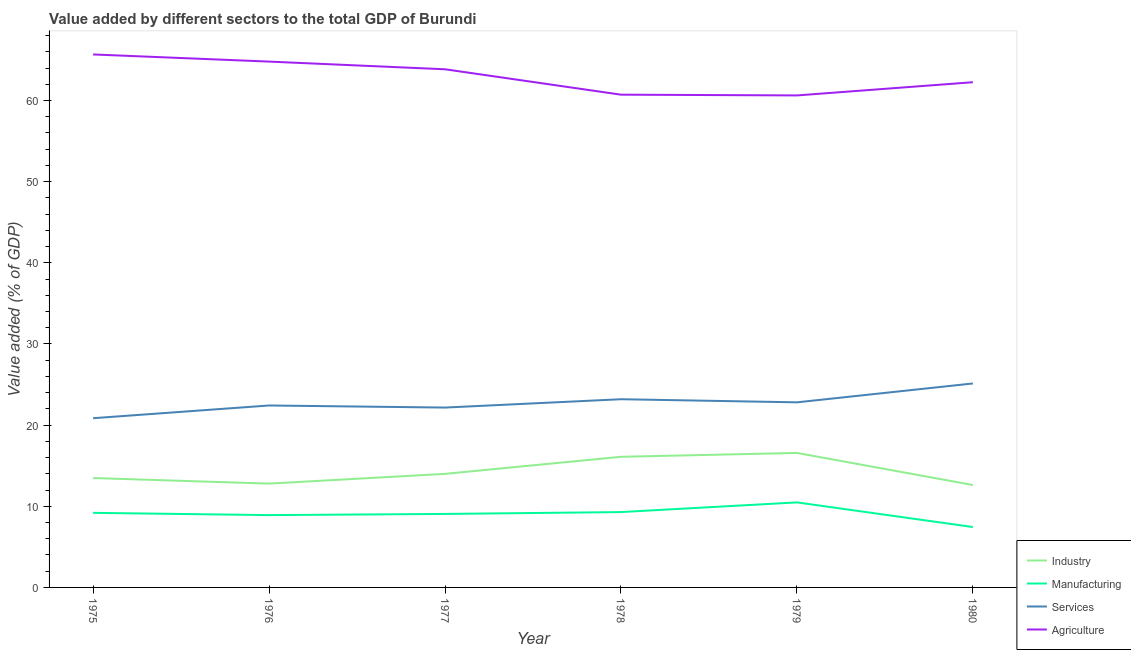How many different coloured lines are there?
Your answer should be very brief. 4. Is the number of lines equal to the number of legend labels?
Offer a very short reply. Yes. What is the value added by agricultural sector in 1976?
Provide a short and direct response. 64.79. Across all years, what is the maximum value added by industrial sector?
Provide a succinct answer. 16.57. Across all years, what is the minimum value added by industrial sector?
Offer a terse response. 12.62. In which year was the value added by services sector maximum?
Ensure brevity in your answer.  1980. In which year was the value added by agricultural sector minimum?
Provide a succinct answer. 1979. What is the total value added by agricultural sector in the graph?
Offer a very short reply. 377.89. What is the difference between the value added by manufacturing sector in 1975 and that in 1979?
Offer a terse response. -1.29. What is the difference between the value added by industrial sector in 1978 and the value added by manufacturing sector in 1975?
Provide a short and direct response. 6.91. What is the average value added by agricultural sector per year?
Your answer should be compact. 62.98. In the year 1979, what is the difference between the value added by manufacturing sector and value added by services sector?
Ensure brevity in your answer.  -12.33. What is the ratio of the value added by industrial sector in 1976 to that in 1978?
Give a very brief answer. 0.79. What is the difference between the highest and the second highest value added by industrial sector?
Offer a terse response. 0.48. What is the difference between the highest and the lowest value added by services sector?
Offer a very short reply. 4.28. In how many years, is the value added by industrial sector greater than the average value added by industrial sector taken over all years?
Provide a succinct answer. 2. Is the sum of the value added by services sector in 1976 and 1979 greater than the maximum value added by industrial sector across all years?
Ensure brevity in your answer.  Yes. Is the value added by agricultural sector strictly less than the value added by industrial sector over the years?
Provide a succinct answer. No. How many years are there in the graph?
Ensure brevity in your answer.  6. Does the graph contain grids?
Give a very brief answer. No. How are the legend labels stacked?
Provide a succinct answer. Vertical. What is the title of the graph?
Keep it short and to the point. Value added by different sectors to the total GDP of Burundi. Does "Minerals" appear as one of the legend labels in the graph?
Your response must be concise. No. What is the label or title of the Y-axis?
Offer a terse response. Value added (% of GDP). What is the Value added (% of GDP) in Industry in 1975?
Ensure brevity in your answer.  13.48. What is the Value added (% of GDP) of Manufacturing in 1975?
Provide a short and direct response. 9.19. What is the Value added (% of GDP) in Services in 1975?
Make the answer very short. 20.85. What is the Value added (% of GDP) in Agriculture in 1975?
Offer a very short reply. 65.67. What is the Value added (% of GDP) of Industry in 1976?
Provide a succinct answer. 12.79. What is the Value added (% of GDP) of Manufacturing in 1976?
Provide a short and direct response. 8.91. What is the Value added (% of GDP) of Services in 1976?
Your answer should be very brief. 22.42. What is the Value added (% of GDP) in Agriculture in 1976?
Give a very brief answer. 64.79. What is the Value added (% of GDP) of Industry in 1977?
Give a very brief answer. 13.99. What is the Value added (% of GDP) of Manufacturing in 1977?
Provide a short and direct response. 9.05. What is the Value added (% of GDP) in Services in 1977?
Make the answer very short. 22.16. What is the Value added (% of GDP) in Agriculture in 1977?
Offer a very short reply. 63.84. What is the Value added (% of GDP) of Industry in 1978?
Your response must be concise. 16.1. What is the Value added (% of GDP) of Manufacturing in 1978?
Your answer should be compact. 9.29. What is the Value added (% of GDP) in Services in 1978?
Ensure brevity in your answer.  23.19. What is the Value added (% of GDP) of Agriculture in 1978?
Provide a short and direct response. 60.71. What is the Value added (% of GDP) of Industry in 1979?
Offer a terse response. 16.57. What is the Value added (% of GDP) of Manufacturing in 1979?
Offer a very short reply. 10.48. What is the Value added (% of GDP) in Services in 1979?
Provide a short and direct response. 22.81. What is the Value added (% of GDP) of Agriculture in 1979?
Your answer should be compact. 60.62. What is the Value added (% of GDP) of Industry in 1980?
Your response must be concise. 12.62. What is the Value added (% of GDP) in Manufacturing in 1980?
Make the answer very short. 7.44. What is the Value added (% of GDP) in Services in 1980?
Give a very brief answer. 25.13. What is the Value added (% of GDP) in Agriculture in 1980?
Ensure brevity in your answer.  62.25. Across all years, what is the maximum Value added (% of GDP) in Industry?
Ensure brevity in your answer.  16.57. Across all years, what is the maximum Value added (% of GDP) of Manufacturing?
Ensure brevity in your answer.  10.48. Across all years, what is the maximum Value added (% of GDP) of Services?
Your response must be concise. 25.13. Across all years, what is the maximum Value added (% of GDP) of Agriculture?
Make the answer very short. 65.67. Across all years, what is the minimum Value added (% of GDP) of Industry?
Provide a short and direct response. 12.62. Across all years, what is the minimum Value added (% of GDP) of Manufacturing?
Your answer should be compact. 7.44. Across all years, what is the minimum Value added (% of GDP) of Services?
Your answer should be compact. 20.85. Across all years, what is the minimum Value added (% of GDP) of Agriculture?
Offer a very short reply. 60.62. What is the total Value added (% of GDP) in Industry in the graph?
Provide a short and direct response. 85.55. What is the total Value added (% of GDP) of Manufacturing in the graph?
Your response must be concise. 54.36. What is the total Value added (% of GDP) of Services in the graph?
Your response must be concise. 136.56. What is the total Value added (% of GDP) in Agriculture in the graph?
Your response must be concise. 377.89. What is the difference between the Value added (% of GDP) of Industry in 1975 and that in 1976?
Your answer should be very brief. 0.69. What is the difference between the Value added (% of GDP) in Manufacturing in 1975 and that in 1976?
Ensure brevity in your answer.  0.28. What is the difference between the Value added (% of GDP) in Services in 1975 and that in 1976?
Give a very brief answer. -1.57. What is the difference between the Value added (% of GDP) of Agriculture in 1975 and that in 1976?
Provide a succinct answer. 0.88. What is the difference between the Value added (% of GDP) in Industry in 1975 and that in 1977?
Make the answer very short. -0.51. What is the difference between the Value added (% of GDP) in Manufacturing in 1975 and that in 1977?
Your answer should be compact. 0.13. What is the difference between the Value added (% of GDP) of Services in 1975 and that in 1977?
Offer a terse response. -1.31. What is the difference between the Value added (% of GDP) of Agriculture in 1975 and that in 1977?
Your answer should be very brief. 1.83. What is the difference between the Value added (% of GDP) of Industry in 1975 and that in 1978?
Provide a succinct answer. -2.62. What is the difference between the Value added (% of GDP) in Manufacturing in 1975 and that in 1978?
Provide a succinct answer. -0.1. What is the difference between the Value added (% of GDP) of Services in 1975 and that in 1978?
Offer a very short reply. -2.34. What is the difference between the Value added (% of GDP) of Agriculture in 1975 and that in 1978?
Your answer should be very brief. 4.96. What is the difference between the Value added (% of GDP) in Industry in 1975 and that in 1979?
Your response must be concise. -3.09. What is the difference between the Value added (% of GDP) of Manufacturing in 1975 and that in 1979?
Give a very brief answer. -1.29. What is the difference between the Value added (% of GDP) of Services in 1975 and that in 1979?
Keep it short and to the point. -1.96. What is the difference between the Value added (% of GDP) of Agriculture in 1975 and that in 1979?
Your answer should be very brief. 5.05. What is the difference between the Value added (% of GDP) in Industry in 1975 and that in 1980?
Keep it short and to the point. 0.86. What is the difference between the Value added (% of GDP) in Manufacturing in 1975 and that in 1980?
Give a very brief answer. 1.75. What is the difference between the Value added (% of GDP) of Services in 1975 and that in 1980?
Provide a short and direct response. -4.28. What is the difference between the Value added (% of GDP) of Agriculture in 1975 and that in 1980?
Your answer should be compact. 3.42. What is the difference between the Value added (% of GDP) in Industry in 1976 and that in 1977?
Provide a short and direct response. -1.2. What is the difference between the Value added (% of GDP) in Manufacturing in 1976 and that in 1977?
Keep it short and to the point. -0.14. What is the difference between the Value added (% of GDP) in Services in 1976 and that in 1977?
Offer a terse response. 0.26. What is the difference between the Value added (% of GDP) of Agriculture in 1976 and that in 1977?
Ensure brevity in your answer.  0.95. What is the difference between the Value added (% of GDP) in Industry in 1976 and that in 1978?
Offer a terse response. -3.3. What is the difference between the Value added (% of GDP) of Manufacturing in 1976 and that in 1978?
Keep it short and to the point. -0.37. What is the difference between the Value added (% of GDP) of Services in 1976 and that in 1978?
Keep it short and to the point. -0.77. What is the difference between the Value added (% of GDP) of Agriculture in 1976 and that in 1978?
Your answer should be compact. 4.08. What is the difference between the Value added (% of GDP) in Industry in 1976 and that in 1979?
Provide a succinct answer. -3.78. What is the difference between the Value added (% of GDP) of Manufacturing in 1976 and that in 1979?
Provide a short and direct response. -1.57. What is the difference between the Value added (% of GDP) of Services in 1976 and that in 1979?
Give a very brief answer. -0.39. What is the difference between the Value added (% of GDP) in Agriculture in 1976 and that in 1979?
Keep it short and to the point. 4.17. What is the difference between the Value added (% of GDP) in Industry in 1976 and that in 1980?
Your answer should be compact. 0.17. What is the difference between the Value added (% of GDP) in Manufacturing in 1976 and that in 1980?
Your answer should be compact. 1.47. What is the difference between the Value added (% of GDP) of Services in 1976 and that in 1980?
Your response must be concise. -2.71. What is the difference between the Value added (% of GDP) of Agriculture in 1976 and that in 1980?
Your answer should be very brief. 2.54. What is the difference between the Value added (% of GDP) in Industry in 1977 and that in 1978?
Provide a succinct answer. -2.1. What is the difference between the Value added (% of GDP) of Manufacturing in 1977 and that in 1978?
Make the answer very short. -0.23. What is the difference between the Value added (% of GDP) of Services in 1977 and that in 1978?
Your response must be concise. -1.03. What is the difference between the Value added (% of GDP) in Agriculture in 1977 and that in 1978?
Your answer should be compact. 3.13. What is the difference between the Value added (% of GDP) of Industry in 1977 and that in 1979?
Keep it short and to the point. -2.58. What is the difference between the Value added (% of GDP) of Manufacturing in 1977 and that in 1979?
Give a very brief answer. -1.42. What is the difference between the Value added (% of GDP) in Services in 1977 and that in 1979?
Give a very brief answer. -0.64. What is the difference between the Value added (% of GDP) in Agriculture in 1977 and that in 1979?
Ensure brevity in your answer.  3.22. What is the difference between the Value added (% of GDP) of Industry in 1977 and that in 1980?
Your answer should be very brief. 1.37. What is the difference between the Value added (% of GDP) in Manufacturing in 1977 and that in 1980?
Your answer should be compact. 1.61. What is the difference between the Value added (% of GDP) of Services in 1977 and that in 1980?
Ensure brevity in your answer.  -2.97. What is the difference between the Value added (% of GDP) in Agriculture in 1977 and that in 1980?
Your answer should be very brief. 1.59. What is the difference between the Value added (% of GDP) in Industry in 1978 and that in 1979?
Offer a very short reply. -0.48. What is the difference between the Value added (% of GDP) in Manufacturing in 1978 and that in 1979?
Keep it short and to the point. -1.19. What is the difference between the Value added (% of GDP) of Services in 1978 and that in 1979?
Provide a succinct answer. 0.38. What is the difference between the Value added (% of GDP) of Agriculture in 1978 and that in 1979?
Keep it short and to the point. 0.09. What is the difference between the Value added (% of GDP) in Industry in 1978 and that in 1980?
Offer a very short reply. 3.48. What is the difference between the Value added (% of GDP) of Manufacturing in 1978 and that in 1980?
Give a very brief answer. 1.84. What is the difference between the Value added (% of GDP) of Services in 1978 and that in 1980?
Ensure brevity in your answer.  -1.94. What is the difference between the Value added (% of GDP) in Agriculture in 1978 and that in 1980?
Ensure brevity in your answer.  -1.54. What is the difference between the Value added (% of GDP) of Industry in 1979 and that in 1980?
Offer a very short reply. 3.95. What is the difference between the Value added (% of GDP) of Manufacturing in 1979 and that in 1980?
Keep it short and to the point. 3.04. What is the difference between the Value added (% of GDP) of Services in 1979 and that in 1980?
Provide a succinct answer. -2.32. What is the difference between the Value added (% of GDP) of Agriculture in 1979 and that in 1980?
Your answer should be compact. -1.63. What is the difference between the Value added (% of GDP) in Industry in 1975 and the Value added (% of GDP) in Manufacturing in 1976?
Give a very brief answer. 4.57. What is the difference between the Value added (% of GDP) in Industry in 1975 and the Value added (% of GDP) in Services in 1976?
Offer a very short reply. -8.94. What is the difference between the Value added (% of GDP) in Industry in 1975 and the Value added (% of GDP) in Agriculture in 1976?
Your answer should be compact. -51.31. What is the difference between the Value added (% of GDP) of Manufacturing in 1975 and the Value added (% of GDP) of Services in 1976?
Make the answer very short. -13.23. What is the difference between the Value added (% of GDP) of Manufacturing in 1975 and the Value added (% of GDP) of Agriculture in 1976?
Offer a very short reply. -55.6. What is the difference between the Value added (% of GDP) in Services in 1975 and the Value added (% of GDP) in Agriculture in 1976?
Offer a very short reply. -43.94. What is the difference between the Value added (% of GDP) in Industry in 1975 and the Value added (% of GDP) in Manufacturing in 1977?
Offer a terse response. 4.42. What is the difference between the Value added (% of GDP) of Industry in 1975 and the Value added (% of GDP) of Services in 1977?
Your answer should be compact. -8.68. What is the difference between the Value added (% of GDP) in Industry in 1975 and the Value added (% of GDP) in Agriculture in 1977?
Make the answer very short. -50.37. What is the difference between the Value added (% of GDP) of Manufacturing in 1975 and the Value added (% of GDP) of Services in 1977?
Offer a terse response. -12.97. What is the difference between the Value added (% of GDP) in Manufacturing in 1975 and the Value added (% of GDP) in Agriculture in 1977?
Provide a succinct answer. -54.66. What is the difference between the Value added (% of GDP) of Services in 1975 and the Value added (% of GDP) of Agriculture in 1977?
Give a very brief answer. -42.99. What is the difference between the Value added (% of GDP) of Industry in 1975 and the Value added (% of GDP) of Manufacturing in 1978?
Provide a short and direct response. 4.19. What is the difference between the Value added (% of GDP) in Industry in 1975 and the Value added (% of GDP) in Services in 1978?
Provide a short and direct response. -9.71. What is the difference between the Value added (% of GDP) in Industry in 1975 and the Value added (% of GDP) in Agriculture in 1978?
Offer a terse response. -47.24. What is the difference between the Value added (% of GDP) of Manufacturing in 1975 and the Value added (% of GDP) of Services in 1978?
Give a very brief answer. -14. What is the difference between the Value added (% of GDP) of Manufacturing in 1975 and the Value added (% of GDP) of Agriculture in 1978?
Offer a terse response. -51.53. What is the difference between the Value added (% of GDP) in Services in 1975 and the Value added (% of GDP) in Agriculture in 1978?
Provide a succinct answer. -39.86. What is the difference between the Value added (% of GDP) in Industry in 1975 and the Value added (% of GDP) in Manufacturing in 1979?
Make the answer very short. 3. What is the difference between the Value added (% of GDP) of Industry in 1975 and the Value added (% of GDP) of Services in 1979?
Give a very brief answer. -9.33. What is the difference between the Value added (% of GDP) in Industry in 1975 and the Value added (% of GDP) in Agriculture in 1979?
Make the answer very short. -47.14. What is the difference between the Value added (% of GDP) in Manufacturing in 1975 and the Value added (% of GDP) in Services in 1979?
Give a very brief answer. -13.62. What is the difference between the Value added (% of GDP) in Manufacturing in 1975 and the Value added (% of GDP) in Agriculture in 1979?
Offer a very short reply. -51.43. What is the difference between the Value added (% of GDP) of Services in 1975 and the Value added (% of GDP) of Agriculture in 1979?
Ensure brevity in your answer.  -39.77. What is the difference between the Value added (% of GDP) of Industry in 1975 and the Value added (% of GDP) of Manufacturing in 1980?
Your answer should be compact. 6.04. What is the difference between the Value added (% of GDP) of Industry in 1975 and the Value added (% of GDP) of Services in 1980?
Keep it short and to the point. -11.65. What is the difference between the Value added (% of GDP) of Industry in 1975 and the Value added (% of GDP) of Agriculture in 1980?
Keep it short and to the point. -48.77. What is the difference between the Value added (% of GDP) of Manufacturing in 1975 and the Value added (% of GDP) of Services in 1980?
Offer a very short reply. -15.94. What is the difference between the Value added (% of GDP) of Manufacturing in 1975 and the Value added (% of GDP) of Agriculture in 1980?
Keep it short and to the point. -53.06. What is the difference between the Value added (% of GDP) of Services in 1975 and the Value added (% of GDP) of Agriculture in 1980?
Give a very brief answer. -41.4. What is the difference between the Value added (% of GDP) in Industry in 1976 and the Value added (% of GDP) in Manufacturing in 1977?
Offer a very short reply. 3.74. What is the difference between the Value added (% of GDP) in Industry in 1976 and the Value added (% of GDP) in Services in 1977?
Make the answer very short. -9.37. What is the difference between the Value added (% of GDP) in Industry in 1976 and the Value added (% of GDP) in Agriculture in 1977?
Offer a terse response. -51.05. What is the difference between the Value added (% of GDP) of Manufacturing in 1976 and the Value added (% of GDP) of Services in 1977?
Offer a terse response. -13.25. What is the difference between the Value added (% of GDP) of Manufacturing in 1976 and the Value added (% of GDP) of Agriculture in 1977?
Provide a succinct answer. -54.93. What is the difference between the Value added (% of GDP) of Services in 1976 and the Value added (% of GDP) of Agriculture in 1977?
Your answer should be very brief. -41.43. What is the difference between the Value added (% of GDP) in Industry in 1976 and the Value added (% of GDP) in Manufacturing in 1978?
Offer a very short reply. 3.51. What is the difference between the Value added (% of GDP) of Industry in 1976 and the Value added (% of GDP) of Services in 1978?
Provide a succinct answer. -10.4. What is the difference between the Value added (% of GDP) of Industry in 1976 and the Value added (% of GDP) of Agriculture in 1978?
Your answer should be very brief. -47.92. What is the difference between the Value added (% of GDP) in Manufacturing in 1976 and the Value added (% of GDP) in Services in 1978?
Offer a very short reply. -14.28. What is the difference between the Value added (% of GDP) of Manufacturing in 1976 and the Value added (% of GDP) of Agriculture in 1978?
Ensure brevity in your answer.  -51.8. What is the difference between the Value added (% of GDP) in Services in 1976 and the Value added (% of GDP) in Agriculture in 1978?
Provide a succinct answer. -38.3. What is the difference between the Value added (% of GDP) of Industry in 1976 and the Value added (% of GDP) of Manufacturing in 1979?
Ensure brevity in your answer.  2.31. What is the difference between the Value added (% of GDP) in Industry in 1976 and the Value added (% of GDP) in Services in 1979?
Your answer should be compact. -10.01. What is the difference between the Value added (% of GDP) of Industry in 1976 and the Value added (% of GDP) of Agriculture in 1979?
Provide a short and direct response. -47.83. What is the difference between the Value added (% of GDP) of Manufacturing in 1976 and the Value added (% of GDP) of Services in 1979?
Your answer should be very brief. -13.9. What is the difference between the Value added (% of GDP) of Manufacturing in 1976 and the Value added (% of GDP) of Agriculture in 1979?
Give a very brief answer. -51.71. What is the difference between the Value added (% of GDP) of Services in 1976 and the Value added (% of GDP) of Agriculture in 1979?
Make the answer very short. -38.2. What is the difference between the Value added (% of GDP) in Industry in 1976 and the Value added (% of GDP) in Manufacturing in 1980?
Your response must be concise. 5.35. What is the difference between the Value added (% of GDP) of Industry in 1976 and the Value added (% of GDP) of Services in 1980?
Provide a short and direct response. -12.34. What is the difference between the Value added (% of GDP) of Industry in 1976 and the Value added (% of GDP) of Agriculture in 1980?
Ensure brevity in your answer.  -49.46. What is the difference between the Value added (% of GDP) of Manufacturing in 1976 and the Value added (% of GDP) of Services in 1980?
Offer a very short reply. -16.22. What is the difference between the Value added (% of GDP) of Manufacturing in 1976 and the Value added (% of GDP) of Agriculture in 1980?
Provide a succinct answer. -53.34. What is the difference between the Value added (% of GDP) of Services in 1976 and the Value added (% of GDP) of Agriculture in 1980?
Offer a very short reply. -39.83. What is the difference between the Value added (% of GDP) of Industry in 1977 and the Value added (% of GDP) of Manufacturing in 1978?
Your response must be concise. 4.71. What is the difference between the Value added (% of GDP) of Industry in 1977 and the Value added (% of GDP) of Services in 1978?
Offer a terse response. -9.2. What is the difference between the Value added (% of GDP) in Industry in 1977 and the Value added (% of GDP) in Agriculture in 1978?
Give a very brief answer. -46.72. What is the difference between the Value added (% of GDP) of Manufacturing in 1977 and the Value added (% of GDP) of Services in 1978?
Keep it short and to the point. -14.14. What is the difference between the Value added (% of GDP) in Manufacturing in 1977 and the Value added (% of GDP) in Agriculture in 1978?
Your answer should be compact. -51.66. What is the difference between the Value added (% of GDP) in Services in 1977 and the Value added (% of GDP) in Agriculture in 1978?
Offer a terse response. -38.55. What is the difference between the Value added (% of GDP) of Industry in 1977 and the Value added (% of GDP) of Manufacturing in 1979?
Provide a short and direct response. 3.52. What is the difference between the Value added (% of GDP) in Industry in 1977 and the Value added (% of GDP) in Services in 1979?
Your answer should be compact. -8.81. What is the difference between the Value added (% of GDP) in Industry in 1977 and the Value added (% of GDP) in Agriculture in 1979?
Make the answer very short. -46.63. What is the difference between the Value added (% of GDP) in Manufacturing in 1977 and the Value added (% of GDP) in Services in 1979?
Provide a short and direct response. -13.75. What is the difference between the Value added (% of GDP) in Manufacturing in 1977 and the Value added (% of GDP) in Agriculture in 1979?
Your answer should be compact. -51.57. What is the difference between the Value added (% of GDP) of Services in 1977 and the Value added (% of GDP) of Agriculture in 1979?
Offer a very short reply. -38.46. What is the difference between the Value added (% of GDP) of Industry in 1977 and the Value added (% of GDP) of Manufacturing in 1980?
Offer a terse response. 6.55. What is the difference between the Value added (% of GDP) in Industry in 1977 and the Value added (% of GDP) in Services in 1980?
Offer a terse response. -11.14. What is the difference between the Value added (% of GDP) in Industry in 1977 and the Value added (% of GDP) in Agriculture in 1980?
Your answer should be very brief. -48.26. What is the difference between the Value added (% of GDP) of Manufacturing in 1977 and the Value added (% of GDP) of Services in 1980?
Ensure brevity in your answer.  -16.08. What is the difference between the Value added (% of GDP) of Manufacturing in 1977 and the Value added (% of GDP) of Agriculture in 1980?
Make the answer very short. -53.2. What is the difference between the Value added (% of GDP) in Services in 1977 and the Value added (% of GDP) in Agriculture in 1980?
Your response must be concise. -40.09. What is the difference between the Value added (% of GDP) of Industry in 1978 and the Value added (% of GDP) of Manufacturing in 1979?
Provide a short and direct response. 5.62. What is the difference between the Value added (% of GDP) of Industry in 1978 and the Value added (% of GDP) of Services in 1979?
Make the answer very short. -6.71. What is the difference between the Value added (% of GDP) of Industry in 1978 and the Value added (% of GDP) of Agriculture in 1979?
Ensure brevity in your answer.  -44.53. What is the difference between the Value added (% of GDP) of Manufacturing in 1978 and the Value added (% of GDP) of Services in 1979?
Keep it short and to the point. -13.52. What is the difference between the Value added (% of GDP) in Manufacturing in 1978 and the Value added (% of GDP) in Agriculture in 1979?
Your response must be concise. -51.34. What is the difference between the Value added (% of GDP) of Services in 1978 and the Value added (% of GDP) of Agriculture in 1979?
Your answer should be very brief. -37.43. What is the difference between the Value added (% of GDP) of Industry in 1978 and the Value added (% of GDP) of Manufacturing in 1980?
Keep it short and to the point. 8.66. What is the difference between the Value added (% of GDP) in Industry in 1978 and the Value added (% of GDP) in Services in 1980?
Make the answer very short. -9.03. What is the difference between the Value added (% of GDP) of Industry in 1978 and the Value added (% of GDP) of Agriculture in 1980?
Your response must be concise. -46.15. What is the difference between the Value added (% of GDP) of Manufacturing in 1978 and the Value added (% of GDP) of Services in 1980?
Provide a succinct answer. -15.85. What is the difference between the Value added (% of GDP) in Manufacturing in 1978 and the Value added (% of GDP) in Agriculture in 1980?
Your response must be concise. -52.96. What is the difference between the Value added (% of GDP) in Services in 1978 and the Value added (% of GDP) in Agriculture in 1980?
Your answer should be very brief. -39.06. What is the difference between the Value added (% of GDP) of Industry in 1979 and the Value added (% of GDP) of Manufacturing in 1980?
Offer a very short reply. 9.13. What is the difference between the Value added (% of GDP) of Industry in 1979 and the Value added (% of GDP) of Services in 1980?
Offer a terse response. -8.56. What is the difference between the Value added (% of GDP) in Industry in 1979 and the Value added (% of GDP) in Agriculture in 1980?
Offer a terse response. -45.68. What is the difference between the Value added (% of GDP) in Manufacturing in 1979 and the Value added (% of GDP) in Services in 1980?
Your answer should be compact. -14.65. What is the difference between the Value added (% of GDP) of Manufacturing in 1979 and the Value added (% of GDP) of Agriculture in 1980?
Your answer should be compact. -51.77. What is the difference between the Value added (% of GDP) in Services in 1979 and the Value added (% of GDP) in Agriculture in 1980?
Keep it short and to the point. -39.44. What is the average Value added (% of GDP) in Industry per year?
Your response must be concise. 14.26. What is the average Value added (% of GDP) in Manufacturing per year?
Your response must be concise. 9.06. What is the average Value added (% of GDP) of Services per year?
Ensure brevity in your answer.  22.76. What is the average Value added (% of GDP) of Agriculture per year?
Provide a succinct answer. 62.98. In the year 1975, what is the difference between the Value added (% of GDP) in Industry and Value added (% of GDP) in Manufacturing?
Offer a terse response. 4.29. In the year 1975, what is the difference between the Value added (% of GDP) of Industry and Value added (% of GDP) of Services?
Your answer should be compact. -7.37. In the year 1975, what is the difference between the Value added (% of GDP) of Industry and Value added (% of GDP) of Agriculture?
Offer a terse response. -52.19. In the year 1975, what is the difference between the Value added (% of GDP) in Manufacturing and Value added (% of GDP) in Services?
Provide a short and direct response. -11.66. In the year 1975, what is the difference between the Value added (% of GDP) in Manufacturing and Value added (% of GDP) in Agriculture?
Provide a short and direct response. -56.48. In the year 1975, what is the difference between the Value added (% of GDP) of Services and Value added (% of GDP) of Agriculture?
Your answer should be compact. -44.82. In the year 1976, what is the difference between the Value added (% of GDP) in Industry and Value added (% of GDP) in Manufacturing?
Keep it short and to the point. 3.88. In the year 1976, what is the difference between the Value added (% of GDP) of Industry and Value added (% of GDP) of Services?
Your answer should be compact. -9.63. In the year 1976, what is the difference between the Value added (% of GDP) of Industry and Value added (% of GDP) of Agriculture?
Provide a short and direct response. -52. In the year 1976, what is the difference between the Value added (% of GDP) in Manufacturing and Value added (% of GDP) in Services?
Provide a short and direct response. -13.51. In the year 1976, what is the difference between the Value added (% of GDP) of Manufacturing and Value added (% of GDP) of Agriculture?
Your response must be concise. -55.88. In the year 1976, what is the difference between the Value added (% of GDP) of Services and Value added (% of GDP) of Agriculture?
Ensure brevity in your answer.  -42.37. In the year 1977, what is the difference between the Value added (% of GDP) in Industry and Value added (% of GDP) in Manufacturing?
Provide a short and direct response. 4.94. In the year 1977, what is the difference between the Value added (% of GDP) in Industry and Value added (% of GDP) in Services?
Offer a very short reply. -8.17. In the year 1977, what is the difference between the Value added (% of GDP) in Industry and Value added (% of GDP) in Agriculture?
Your response must be concise. -49.85. In the year 1977, what is the difference between the Value added (% of GDP) in Manufacturing and Value added (% of GDP) in Services?
Your answer should be compact. -13.11. In the year 1977, what is the difference between the Value added (% of GDP) in Manufacturing and Value added (% of GDP) in Agriculture?
Give a very brief answer. -54.79. In the year 1977, what is the difference between the Value added (% of GDP) of Services and Value added (% of GDP) of Agriculture?
Your answer should be very brief. -41.68. In the year 1978, what is the difference between the Value added (% of GDP) of Industry and Value added (% of GDP) of Manufacturing?
Your answer should be very brief. 6.81. In the year 1978, what is the difference between the Value added (% of GDP) of Industry and Value added (% of GDP) of Services?
Provide a succinct answer. -7.09. In the year 1978, what is the difference between the Value added (% of GDP) of Industry and Value added (% of GDP) of Agriculture?
Your answer should be very brief. -44.62. In the year 1978, what is the difference between the Value added (% of GDP) in Manufacturing and Value added (% of GDP) in Services?
Offer a very short reply. -13.9. In the year 1978, what is the difference between the Value added (% of GDP) of Manufacturing and Value added (% of GDP) of Agriculture?
Offer a very short reply. -51.43. In the year 1978, what is the difference between the Value added (% of GDP) of Services and Value added (% of GDP) of Agriculture?
Your answer should be very brief. -37.53. In the year 1979, what is the difference between the Value added (% of GDP) of Industry and Value added (% of GDP) of Manufacturing?
Provide a succinct answer. 6.09. In the year 1979, what is the difference between the Value added (% of GDP) of Industry and Value added (% of GDP) of Services?
Make the answer very short. -6.24. In the year 1979, what is the difference between the Value added (% of GDP) in Industry and Value added (% of GDP) in Agriculture?
Ensure brevity in your answer.  -44.05. In the year 1979, what is the difference between the Value added (% of GDP) in Manufacturing and Value added (% of GDP) in Services?
Provide a succinct answer. -12.33. In the year 1979, what is the difference between the Value added (% of GDP) in Manufacturing and Value added (% of GDP) in Agriculture?
Keep it short and to the point. -50.14. In the year 1979, what is the difference between the Value added (% of GDP) of Services and Value added (% of GDP) of Agriculture?
Your answer should be compact. -37.82. In the year 1980, what is the difference between the Value added (% of GDP) of Industry and Value added (% of GDP) of Manufacturing?
Provide a short and direct response. 5.18. In the year 1980, what is the difference between the Value added (% of GDP) in Industry and Value added (% of GDP) in Services?
Offer a terse response. -12.51. In the year 1980, what is the difference between the Value added (% of GDP) of Industry and Value added (% of GDP) of Agriculture?
Offer a terse response. -49.63. In the year 1980, what is the difference between the Value added (% of GDP) of Manufacturing and Value added (% of GDP) of Services?
Give a very brief answer. -17.69. In the year 1980, what is the difference between the Value added (% of GDP) in Manufacturing and Value added (% of GDP) in Agriculture?
Your answer should be compact. -54.81. In the year 1980, what is the difference between the Value added (% of GDP) of Services and Value added (% of GDP) of Agriculture?
Provide a short and direct response. -37.12. What is the ratio of the Value added (% of GDP) of Industry in 1975 to that in 1976?
Offer a very short reply. 1.05. What is the ratio of the Value added (% of GDP) in Manufacturing in 1975 to that in 1976?
Your response must be concise. 1.03. What is the ratio of the Value added (% of GDP) in Services in 1975 to that in 1976?
Offer a very short reply. 0.93. What is the ratio of the Value added (% of GDP) in Agriculture in 1975 to that in 1976?
Make the answer very short. 1.01. What is the ratio of the Value added (% of GDP) in Industry in 1975 to that in 1977?
Offer a terse response. 0.96. What is the ratio of the Value added (% of GDP) in Manufacturing in 1975 to that in 1977?
Provide a short and direct response. 1.01. What is the ratio of the Value added (% of GDP) of Services in 1975 to that in 1977?
Offer a terse response. 0.94. What is the ratio of the Value added (% of GDP) in Agriculture in 1975 to that in 1977?
Your answer should be compact. 1.03. What is the ratio of the Value added (% of GDP) of Industry in 1975 to that in 1978?
Ensure brevity in your answer.  0.84. What is the ratio of the Value added (% of GDP) in Manufacturing in 1975 to that in 1978?
Provide a succinct answer. 0.99. What is the ratio of the Value added (% of GDP) of Services in 1975 to that in 1978?
Provide a succinct answer. 0.9. What is the ratio of the Value added (% of GDP) in Agriculture in 1975 to that in 1978?
Your answer should be very brief. 1.08. What is the ratio of the Value added (% of GDP) of Industry in 1975 to that in 1979?
Offer a very short reply. 0.81. What is the ratio of the Value added (% of GDP) in Manufacturing in 1975 to that in 1979?
Give a very brief answer. 0.88. What is the ratio of the Value added (% of GDP) in Services in 1975 to that in 1979?
Provide a succinct answer. 0.91. What is the ratio of the Value added (% of GDP) in Industry in 1975 to that in 1980?
Ensure brevity in your answer.  1.07. What is the ratio of the Value added (% of GDP) of Manufacturing in 1975 to that in 1980?
Your answer should be compact. 1.24. What is the ratio of the Value added (% of GDP) of Services in 1975 to that in 1980?
Your answer should be compact. 0.83. What is the ratio of the Value added (% of GDP) of Agriculture in 1975 to that in 1980?
Give a very brief answer. 1.05. What is the ratio of the Value added (% of GDP) of Industry in 1976 to that in 1977?
Provide a succinct answer. 0.91. What is the ratio of the Value added (% of GDP) of Manufacturing in 1976 to that in 1977?
Provide a short and direct response. 0.98. What is the ratio of the Value added (% of GDP) of Services in 1976 to that in 1977?
Provide a short and direct response. 1.01. What is the ratio of the Value added (% of GDP) of Agriculture in 1976 to that in 1977?
Your answer should be very brief. 1.01. What is the ratio of the Value added (% of GDP) of Industry in 1976 to that in 1978?
Provide a succinct answer. 0.79. What is the ratio of the Value added (% of GDP) of Manufacturing in 1976 to that in 1978?
Provide a short and direct response. 0.96. What is the ratio of the Value added (% of GDP) in Services in 1976 to that in 1978?
Give a very brief answer. 0.97. What is the ratio of the Value added (% of GDP) of Agriculture in 1976 to that in 1978?
Provide a succinct answer. 1.07. What is the ratio of the Value added (% of GDP) of Industry in 1976 to that in 1979?
Your answer should be very brief. 0.77. What is the ratio of the Value added (% of GDP) in Manufacturing in 1976 to that in 1979?
Your answer should be very brief. 0.85. What is the ratio of the Value added (% of GDP) in Agriculture in 1976 to that in 1979?
Provide a short and direct response. 1.07. What is the ratio of the Value added (% of GDP) in Industry in 1976 to that in 1980?
Offer a terse response. 1.01. What is the ratio of the Value added (% of GDP) in Manufacturing in 1976 to that in 1980?
Ensure brevity in your answer.  1.2. What is the ratio of the Value added (% of GDP) in Services in 1976 to that in 1980?
Your response must be concise. 0.89. What is the ratio of the Value added (% of GDP) in Agriculture in 1976 to that in 1980?
Ensure brevity in your answer.  1.04. What is the ratio of the Value added (% of GDP) in Industry in 1977 to that in 1978?
Your answer should be compact. 0.87. What is the ratio of the Value added (% of GDP) in Manufacturing in 1977 to that in 1978?
Provide a short and direct response. 0.98. What is the ratio of the Value added (% of GDP) in Services in 1977 to that in 1978?
Provide a succinct answer. 0.96. What is the ratio of the Value added (% of GDP) in Agriculture in 1977 to that in 1978?
Your answer should be compact. 1.05. What is the ratio of the Value added (% of GDP) of Industry in 1977 to that in 1979?
Ensure brevity in your answer.  0.84. What is the ratio of the Value added (% of GDP) in Manufacturing in 1977 to that in 1979?
Ensure brevity in your answer.  0.86. What is the ratio of the Value added (% of GDP) in Services in 1977 to that in 1979?
Provide a succinct answer. 0.97. What is the ratio of the Value added (% of GDP) in Agriculture in 1977 to that in 1979?
Ensure brevity in your answer.  1.05. What is the ratio of the Value added (% of GDP) in Industry in 1977 to that in 1980?
Offer a very short reply. 1.11. What is the ratio of the Value added (% of GDP) in Manufacturing in 1977 to that in 1980?
Make the answer very short. 1.22. What is the ratio of the Value added (% of GDP) of Services in 1977 to that in 1980?
Keep it short and to the point. 0.88. What is the ratio of the Value added (% of GDP) in Agriculture in 1977 to that in 1980?
Keep it short and to the point. 1.03. What is the ratio of the Value added (% of GDP) in Industry in 1978 to that in 1979?
Your answer should be very brief. 0.97. What is the ratio of the Value added (% of GDP) of Manufacturing in 1978 to that in 1979?
Ensure brevity in your answer.  0.89. What is the ratio of the Value added (% of GDP) in Services in 1978 to that in 1979?
Provide a succinct answer. 1.02. What is the ratio of the Value added (% of GDP) in Agriculture in 1978 to that in 1979?
Your answer should be very brief. 1. What is the ratio of the Value added (% of GDP) of Industry in 1978 to that in 1980?
Offer a terse response. 1.28. What is the ratio of the Value added (% of GDP) in Manufacturing in 1978 to that in 1980?
Make the answer very short. 1.25. What is the ratio of the Value added (% of GDP) of Services in 1978 to that in 1980?
Offer a terse response. 0.92. What is the ratio of the Value added (% of GDP) in Agriculture in 1978 to that in 1980?
Your response must be concise. 0.98. What is the ratio of the Value added (% of GDP) of Industry in 1979 to that in 1980?
Ensure brevity in your answer.  1.31. What is the ratio of the Value added (% of GDP) of Manufacturing in 1979 to that in 1980?
Offer a terse response. 1.41. What is the ratio of the Value added (% of GDP) in Services in 1979 to that in 1980?
Keep it short and to the point. 0.91. What is the ratio of the Value added (% of GDP) of Agriculture in 1979 to that in 1980?
Offer a terse response. 0.97. What is the difference between the highest and the second highest Value added (% of GDP) of Industry?
Provide a short and direct response. 0.48. What is the difference between the highest and the second highest Value added (% of GDP) of Manufacturing?
Your response must be concise. 1.19. What is the difference between the highest and the second highest Value added (% of GDP) in Services?
Provide a short and direct response. 1.94. What is the difference between the highest and the second highest Value added (% of GDP) in Agriculture?
Make the answer very short. 0.88. What is the difference between the highest and the lowest Value added (% of GDP) of Industry?
Ensure brevity in your answer.  3.95. What is the difference between the highest and the lowest Value added (% of GDP) of Manufacturing?
Provide a short and direct response. 3.04. What is the difference between the highest and the lowest Value added (% of GDP) in Services?
Your answer should be very brief. 4.28. What is the difference between the highest and the lowest Value added (% of GDP) of Agriculture?
Your answer should be very brief. 5.05. 